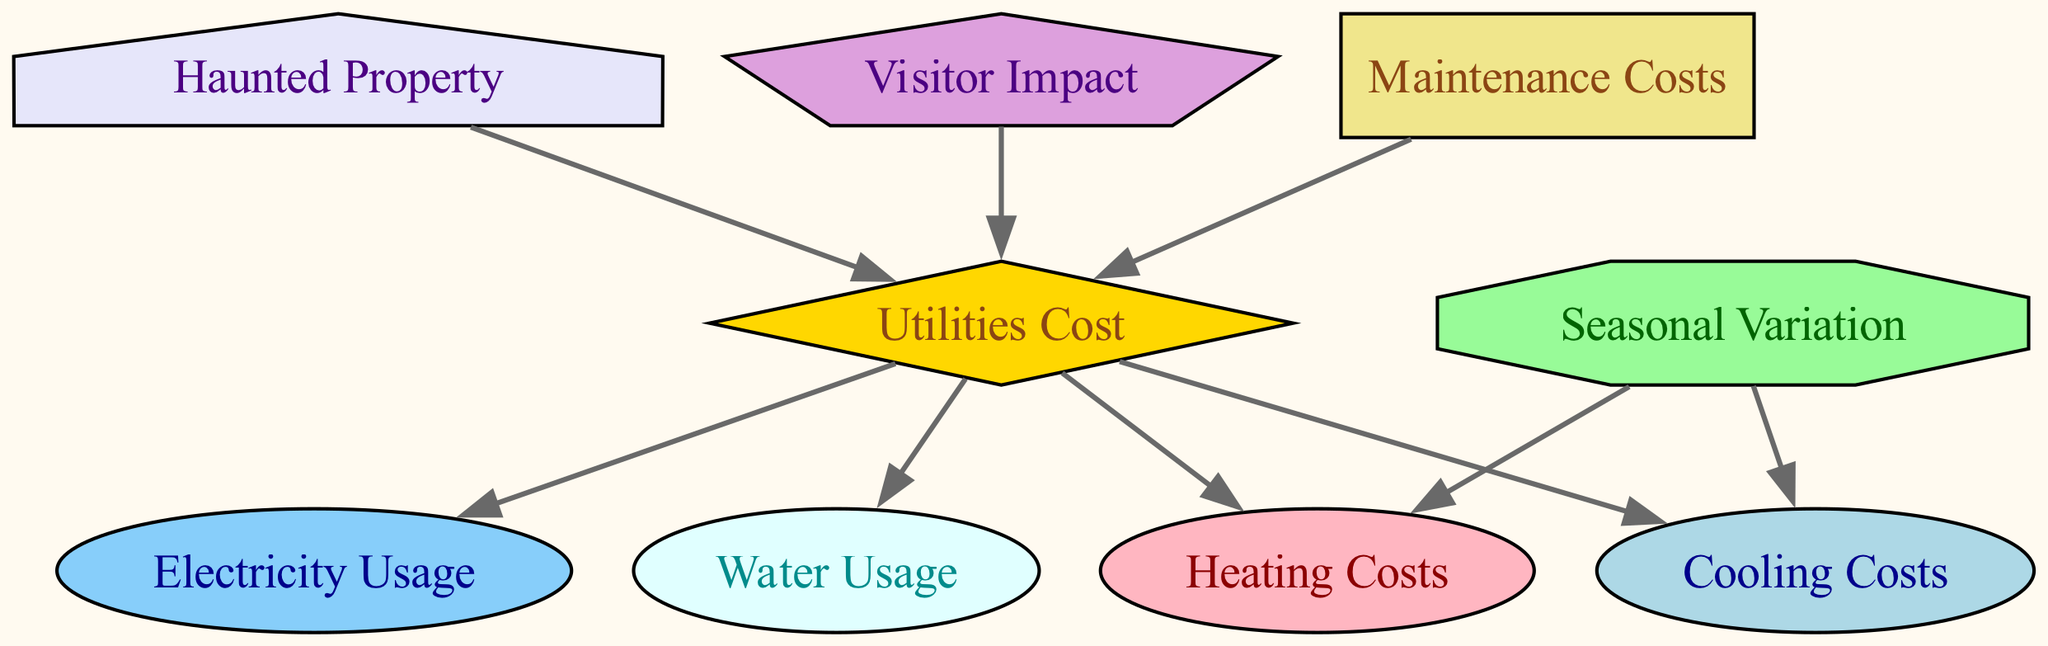What is the total number of nodes in the diagram? The diagram contains 9 nodes: Haunted Property, Utilities Cost, Seasonal Variation, Electricity Usage, Heating Costs, Cooling Costs, Water Usage, Visitor Impact, and Maintenance Costs.
Answer: 9 How many edges are there in total? There are 9 edges that connect the nodes, showing the relationships between them.
Answer: 9 What impacts the Utilities Cost? The Utilities Cost is impacted by Electricity Usage, Heating Costs, Cooling Costs, Water Usage, Visitor Impact, and Maintenance Costs.
Answer: Six factors Which node connects directly to Seasonal Variation? The Seasonal Variation connects directly to Heating Costs and Cooling Costs, illustrating how seasonal changes influence these costs.
Answer: Heating Costs and Cooling Costs What type of shape is used for Utilities Cost? The shape representing Utilities Cost in the diagram is a diamond, indicating its central role in the cost analysis.
Answer: Diamond Which node does Visitor Impact influence? The Visitor Impact influences Utilities Cost, showing that the number of visitors can affect the overall utility expenses.
Answer: Utilities Cost What kind of relationship exists between Haunted Property and Utilities Cost? The relationship shows that a Haunted Property leads to or is associated with Utilities Cost, indicating that the property is the source of utility expenses.
Answer: Direct influence Which costs are influenced by Seasonal Variation? Seasonal Variation influences Heating Costs and Cooling Costs, highlighting how different seasons affect these utility expenses.
Answer: Heating Costs and Cooling Costs What shape represents Maintenance Costs? Maintenance Costs are represented by a rectangle shape in the diagram, suggesting a standard element in cost considerations.
Answer: Rectangle 